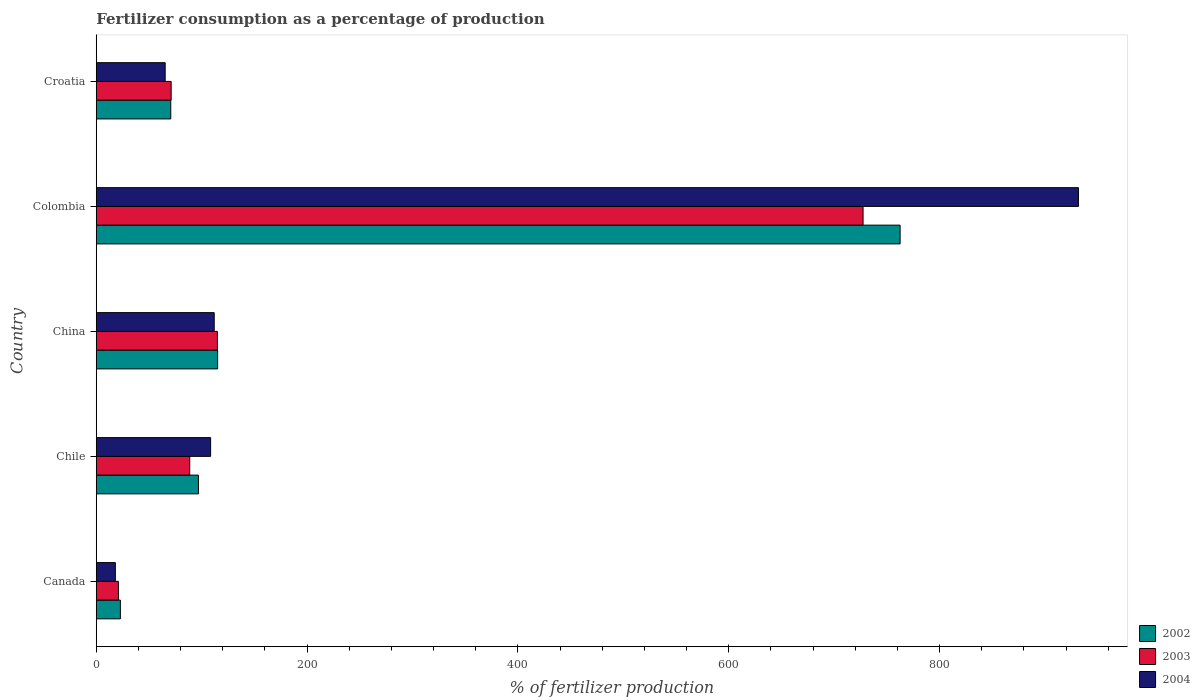How many different coloured bars are there?
Offer a very short reply. 3. Are the number of bars per tick equal to the number of legend labels?
Ensure brevity in your answer.  Yes. How many bars are there on the 1st tick from the top?
Give a very brief answer. 3. What is the label of the 2nd group of bars from the top?
Keep it short and to the point. Colombia. What is the percentage of fertilizers consumed in 2002 in Colombia?
Ensure brevity in your answer.  762.5. Across all countries, what is the maximum percentage of fertilizers consumed in 2003?
Provide a succinct answer. 727.37. Across all countries, what is the minimum percentage of fertilizers consumed in 2002?
Provide a succinct answer. 22.89. In which country was the percentage of fertilizers consumed in 2004 maximum?
Make the answer very short. Colombia. In which country was the percentage of fertilizers consumed in 2003 minimum?
Ensure brevity in your answer.  Canada. What is the total percentage of fertilizers consumed in 2003 in the graph?
Give a very brief answer. 1022.99. What is the difference between the percentage of fertilizers consumed in 2004 in Canada and that in Chile?
Provide a succinct answer. -90.37. What is the difference between the percentage of fertilizers consumed in 2003 in Canada and the percentage of fertilizers consumed in 2002 in Colombia?
Offer a very short reply. -741.5. What is the average percentage of fertilizers consumed in 2004 per country?
Give a very brief answer. 247.1. What is the difference between the percentage of fertilizers consumed in 2002 and percentage of fertilizers consumed in 2003 in Colombia?
Your answer should be compact. 35.14. In how many countries, is the percentage of fertilizers consumed in 2002 greater than 240 %?
Ensure brevity in your answer.  1. What is the ratio of the percentage of fertilizers consumed in 2003 in Colombia to that in Croatia?
Ensure brevity in your answer.  10.24. What is the difference between the highest and the second highest percentage of fertilizers consumed in 2003?
Your response must be concise. 612.45. What is the difference between the highest and the lowest percentage of fertilizers consumed in 2002?
Make the answer very short. 739.62. What does the 3rd bar from the top in Chile represents?
Keep it short and to the point. 2002. What does the 3rd bar from the bottom in Croatia represents?
Ensure brevity in your answer.  2004. How many bars are there?
Your answer should be compact. 15. Are all the bars in the graph horizontal?
Provide a short and direct response. Yes. Are the values on the major ticks of X-axis written in scientific E-notation?
Provide a succinct answer. No. How many legend labels are there?
Ensure brevity in your answer.  3. How are the legend labels stacked?
Your answer should be compact. Vertical. What is the title of the graph?
Give a very brief answer. Fertilizer consumption as a percentage of production. What is the label or title of the X-axis?
Make the answer very short. % of fertilizer production. What is the % of fertilizer production in 2002 in Canada?
Your answer should be compact. 22.89. What is the % of fertilizer production of 2003 in Canada?
Keep it short and to the point. 21. What is the % of fertilizer production in 2004 in Canada?
Make the answer very short. 18.12. What is the % of fertilizer production in 2002 in Chile?
Your answer should be very brief. 96.91. What is the % of fertilizer production of 2003 in Chile?
Ensure brevity in your answer.  88.66. What is the % of fertilizer production of 2004 in Chile?
Make the answer very short. 108.48. What is the % of fertilizer production in 2002 in China?
Your answer should be compact. 115.12. What is the % of fertilizer production in 2003 in China?
Offer a very short reply. 114.92. What is the % of fertilizer production in 2004 in China?
Ensure brevity in your answer.  111.88. What is the % of fertilizer production of 2002 in Colombia?
Provide a succinct answer. 762.5. What is the % of fertilizer production of 2003 in Colombia?
Offer a terse response. 727.37. What is the % of fertilizer production in 2004 in Colombia?
Your response must be concise. 931.67. What is the % of fertilizer production of 2002 in Croatia?
Ensure brevity in your answer.  70.67. What is the % of fertilizer production in 2003 in Croatia?
Your answer should be compact. 71.05. What is the % of fertilizer production in 2004 in Croatia?
Make the answer very short. 65.37. Across all countries, what is the maximum % of fertilizer production in 2002?
Keep it short and to the point. 762.5. Across all countries, what is the maximum % of fertilizer production in 2003?
Provide a succinct answer. 727.37. Across all countries, what is the maximum % of fertilizer production of 2004?
Your response must be concise. 931.67. Across all countries, what is the minimum % of fertilizer production of 2002?
Your answer should be very brief. 22.89. Across all countries, what is the minimum % of fertilizer production of 2003?
Offer a very short reply. 21. Across all countries, what is the minimum % of fertilizer production in 2004?
Offer a very short reply. 18.12. What is the total % of fertilizer production in 2002 in the graph?
Offer a terse response. 1068.1. What is the total % of fertilizer production in 2003 in the graph?
Your answer should be compact. 1022.99. What is the total % of fertilizer production in 2004 in the graph?
Your answer should be very brief. 1235.52. What is the difference between the % of fertilizer production of 2002 in Canada and that in Chile?
Your answer should be compact. -74.03. What is the difference between the % of fertilizer production of 2003 in Canada and that in Chile?
Offer a terse response. -67.66. What is the difference between the % of fertilizer production in 2004 in Canada and that in Chile?
Offer a terse response. -90.37. What is the difference between the % of fertilizer production in 2002 in Canada and that in China?
Your answer should be compact. -92.24. What is the difference between the % of fertilizer production in 2003 in Canada and that in China?
Offer a very short reply. -93.91. What is the difference between the % of fertilizer production of 2004 in Canada and that in China?
Offer a terse response. -93.77. What is the difference between the % of fertilizer production in 2002 in Canada and that in Colombia?
Your answer should be compact. -739.62. What is the difference between the % of fertilizer production in 2003 in Canada and that in Colombia?
Your response must be concise. -706.36. What is the difference between the % of fertilizer production in 2004 in Canada and that in Colombia?
Ensure brevity in your answer.  -913.55. What is the difference between the % of fertilizer production in 2002 in Canada and that in Croatia?
Provide a succinct answer. -47.78. What is the difference between the % of fertilizer production of 2003 in Canada and that in Croatia?
Keep it short and to the point. -50.04. What is the difference between the % of fertilizer production of 2004 in Canada and that in Croatia?
Keep it short and to the point. -47.26. What is the difference between the % of fertilizer production of 2002 in Chile and that in China?
Keep it short and to the point. -18.21. What is the difference between the % of fertilizer production in 2003 in Chile and that in China?
Your answer should be compact. -26.26. What is the difference between the % of fertilizer production in 2004 in Chile and that in China?
Offer a terse response. -3.4. What is the difference between the % of fertilizer production in 2002 in Chile and that in Colombia?
Your answer should be very brief. -665.59. What is the difference between the % of fertilizer production in 2003 in Chile and that in Colombia?
Your response must be concise. -638.71. What is the difference between the % of fertilizer production in 2004 in Chile and that in Colombia?
Offer a terse response. -823.18. What is the difference between the % of fertilizer production of 2002 in Chile and that in Croatia?
Your answer should be very brief. 26.24. What is the difference between the % of fertilizer production in 2003 in Chile and that in Croatia?
Ensure brevity in your answer.  17.61. What is the difference between the % of fertilizer production in 2004 in Chile and that in Croatia?
Ensure brevity in your answer.  43.11. What is the difference between the % of fertilizer production of 2002 in China and that in Colombia?
Provide a short and direct response. -647.38. What is the difference between the % of fertilizer production of 2003 in China and that in Colombia?
Make the answer very short. -612.45. What is the difference between the % of fertilizer production in 2004 in China and that in Colombia?
Ensure brevity in your answer.  -819.79. What is the difference between the % of fertilizer production of 2002 in China and that in Croatia?
Your answer should be compact. 44.45. What is the difference between the % of fertilizer production of 2003 in China and that in Croatia?
Your answer should be very brief. 43.87. What is the difference between the % of fertilizer production of 2004 in China and that in Croatia?
Provide a succinct answer. 46.51. What is the difference between the % of fertilizer production in 2002 in Colombia and that in Croatia?
Make the answer very short. 691.83. What is the difference between the % of fertilizer production in 2003 in Colombia and that in Croatia?
Provide a succinct answer. 656.32. What is the difference between the % of fertilizer production in 2004 in Colombia and that in Croatia?
Your response must be concise. 866.29. What is the difference between the % of fertilizer production in 2002 in Canada and the % of fertilizer production in 2003 in Chile?
Offer a very short reply. -65.77. What is the difference between the % of fertilizer production in 2002 in Canada and the % of fertilizer production in 2004 in Chile?
Provide a short and direct response. -85.6. What is the difference between the % of fertilizer production of 2003 in Canada and the % of fertilizer production of 2004 in Chile?
Your answer should be very brief. -87.48. What is the difference between the % of fertilizer production in 2002 in Canada and the % of fertilizer production in 2003 in China?
Provide a succinct answer. -92.03. What is the difference between the % of fertilizer production of 2002 in Canada and the % of fertilizer production of 2004 in China?
Your answer should be compact. -88.99. What is the difference between the % of fertilizer production of 2003 in Canada and the % of fertilizer production of 2004 in China?
Your response must be concise. -90.88. What is the difference between the % of fertilizer production in 2002 in Canada and the % of fertilizer production in 2003 in Colombia?
Provide a short and direct response. -704.48. What is the difference between the % of fertilizer production of 2002 in Canada and the % of fertilizer production of 2004 in Colombia?
Your response must be concise. -908.78. What is the difference between the % of fertilizer production of 2003 in Canada and the % of fertilizer production of 2004 in Colombia?
Provide a short and direct response. -910.66. What is the difference between the % of fertilizer production in 2002 in Canada and the % of fertilizer production in 2003 in Croatia?
Offer a terse response. -48.16. What is the difference between the % of fertilizer production in 2002 in Canada and the % of fertilizer production in 2004 in Croatia?
Offer a terse response. -42.49. What is the difference between the % of fertilizer production of 2003 in Canada and the % of fertilizer production of 2004 in Croatia?
Your answer should be compact. -44.37. What is the difference between the % of fertilizer production of 2002 in Chile and the % of fertilizer production of 2003 in China?
Keep it short and to the point. -18. What is the difference between the % of fertilizer production of 2002 in Chile and the % of fertilizer production of 2004 in China?
Offer a very short reply. -14.97. What is the difference between the % of fertilizer production in 2003 in Chile and the % of fertilizer production in 2004 in China?
Give a very brief answer. -23.22. What is the difference between the % of fertilizer production in 2002 in Chile and the % of fertilizer production in 2003 in Colombia?
Ensure brevity in your answer.  -630.45. What is the difference between the % of fertilizer production of 2002 in Chile and the % of fertilizer production of 2004 in Colombia?
Your answer should be very brief. -834.75. What is the difference between the % of fertilizer production of 2003 in Chile and the % of fertilizer production of 2004 in Colombia?
Your answer should be very brief. -843.01. What is the difference between the % of fertilizer production of 2002 in Chile and the % of fertilizer production of 2003 in Croatia?
Your answer should be compact. 25.87. What is the difference between the % of fertilizer production of 2002 in Chile and the % of fertilizer production of 2004 in Croatia?
Your answer should be compact. 31.54. What is the difference between the % of fertilizer production in 2003 in Chile and the % of fertilizer production in 2004 in Croatia?
Provide a short and direct response. 23.29. What is the difference between the % of fertilizer production of 2002 in China and the % of fertilizer production of 2003 in Colombia?
Your answer should be very brief. -612.25. What is the difference between the % of fertilizer production of 2002 in China and the % of fertilizer production of 2004 in Colombia?
Provide a short and direct response. -816.54. What is the difference between the % of fertilizer production in 2003 in China and the % of fertilizer production in 2004 in Colombia?
Give a very brief answer. -816.75. What is the difference between the % of fertilizer production of 2002 in China and the % of fertilizer production of 2003 in Croatia?
Your answer should be very brief. 44.07. What is the difference between the % of fertilizer production of 2002 in China and the % of fertilizer production of 2004 in Croatia?
Give a very brief answer. 49.75. What is the difference between the % of fertilizer production of 2003 in China and the % of fertilizer production of 2004 in Croatia?
Your answer should be compact. 49.54. What is the difference between the % of fertilizer production of 2002 in Colombia and the % of fertilizer production of 2003 in Croatia?
Offer a very short reply. 691.46. What is the difference between the % of fertilizer production in 2002 in Colombia and the % of fertilizer production in 2004 in Croatia?
Your answer should be compact. 697.13. What is the difference between the % of fertilizer production of 2003 in Colombia and the % of fertilizer production of 2004 in Croatia?
Give a very brief answer. 661.99. What is the average % of fertilizer production of 2002 per country?
Provide a succinct answer. 213.62. What is the average % of fertilizer production of 2003 per country?
Give a very brief answer. 204.6. What is the average % of fertilizer production of 2004 per country?
Make the answer very short. 247.1. What is the difference between the % of fertilizer production in 2002 and % of fertilizer production in 2003 in Canada?
Provide a succinct answer. 1.88. What is the difference between the % of fertilizer production in 2002 and % of fertilizer production in 2004 in Canada?
Offer a terse response. 4.77. What is the difference between the % of fertilizer production in 2003 and % of fertilizer production in 2004 in Canada?
Give a very brief answer. 2.89. What is the difference between the % of fertilizer production in 2002 and % of fertilizer production in 2003 in Chile?
Keep it short and to the point. 8.25. What is the difference between the % of fertilizer production in 2002 and % of fertilizer production in 2004 in Chile?
Your answer should be compact. -11.57. What is the difference between the % of fertilizer production in 2003 and % of fertilizer production in 2004 in Chile?
Your response must be concise. -19.82. What is the difference between the % of fertilizer production of 2002 and % of fertilizer production of 2003 in China?
Offer a terse response. 0.21. What is the difference between the % of fertilizer production in 2002 and % of fertilizer production in 2004 in China?
Give a very brief answer. 3.24. What is the difference between the % of fertilizer production of 2003 and % of fertilizer production of 2004 in China?
Your answer should be very brief. 3.03. What is the difference between the % of fertilizer production of 2002 and % of fertilizer production of 2003 in Colombia?
Give a very brief answer. 35.14. What is the difference between the % of fertilizer production in 2002 and % of fertilizer production in 2004 in Colombia?
Your answer should be very brief. -169.16. What is the difference between the % of fertilizer production of 2003 and % of fertilizer production of 2004 in Colombia?
Your answer should be compact. -204.3. What is the difference between the % of fertilizer production in 2002 and % of fertilizer production in 2003 in Croatia?
Offer a very short reply. -0.38. What is the difference between the % of fertilizer production in 2002 and % of fertilizer production in 2004 in Croatia?
Keep it short and to the point. 5.3. What is the difference between the % of fertilizer production of 2003 and % of fertilizer production of 2004 in Croatia?
Give a very brief answer. 5.67. What is the ratio of the % of fertilizer production of 2002 in Canada to that in Chile?
Ensure brevity in your answer.  0.24. What is the ratio of the % of fertilizer production of 2003 in Canada to that in Chile?
Keep it short and to the point. 0.24. What is the ratio of the % of fertilizer production of 2004 in Canada to that in Chile?
Give a very brief answer. 0.17. What is the ratio of the % of fertilizer production of 2002 in Canada to that in China?
Your answer should be compact. 0.2. What is the ratio of the % of fertilizer production in 2003 in Canada to that in China?
Offer a very short reply. 0.18. What is the ratio of the % of fertilizer production of 2004 in Canada to that in China?
Ensure brevity in your answer.  0.16. What is the ratio of the % of fertilizer production in 2002 in Canada to that in Colombia?
Ensure brevity in your answer.  0.03. What is the ratio of the % of fertilizer production in 2003 in Canada to that in Colombia?
Your response must be concise. 0.03. What is the ratio of the % of fertilizer production of 2004 in Canada to that in Colombia?
Your answer should be compact. 0.02. What is the ratio of the % of fertilizer production in 2002 in Canada to that in Croatia?
Your answer should be very brief. 0.32. What is the ratio of the % of fertilizer production of 2003 in Canada to that in Croatia?
Offer a very short reply. 0.3. What is the ratio of the % of fertilizer production in 2004 in Canada to that in Croatia?
Make the answer very short. 0.28. What is the ratio of the % of fertilizer production in 2002 in Chile to that in China?
Make the answer very short. 0.84. What is the ratio of the % of fertilizer production in 2003 in Chile to that in China?
Offer a terse response. 0.77. What is the ratio of the % of fertilizer production in 2004 in Chile to that in China?
Offer a very short reply. 0.97. What is the ratio of the % of fertilizer production of 2002 in Chile to that in Colombia?
Offer a terse response. 0.13. What is the ratio of the % of fertilizer production of 2003 in Chile to that in Colombia?
Keep it short and to the point. 0.12. What is the ratio of the % of fertilizer production of 2004 in Chile to that in Colombia?
Your response must be concise. 0.12. What is the ratio of the % of fertilizer production in 2002 in Chile to that in Croatia?
Offer a very short reply. 1.37. What is the ratio of the % of fertilizer production of 2003 in Chile to that in Croatia?
Provide a succinct answer. 1.25. What is the ratio of the % of fertilizer production of 2004 in Chile to that in Croatia?
Offer a terse response. 1.66. What is the ratio of the % of fertilizer production in 2002 in China to that in Colombia?
Offer a terse response. 0.15. What is the ratio of the % of fertilizer production in 2003 in China to that in Colombia?
Provide a short and direct response. 0.16. What is the ratio of the % of fertilizer production of 2004 in China to that in Colombia?
Offer a very short reply. 0.12. What is the ratio of the % of fertilizer production in 2002 in China to that in Croatia?
Provide a succinct answer. 1.63. What is the ratio of the % of fertilizer production of 2003 in China to that in Croatia?
Keep it short and to the point. 1.62. What is the ratio of the % of fertilizer production of 2004 in China to that in Croatia?
Give a very brief answer. 1.71. What is the ratio of the % of fertilizer production in 2002 in Colombia to that in Croatia?
Offer a terse response. 10.79. What is the ratio of the % of fertilizer production in 2003 in Colombia to that in Croatia?
Make the answer very short. 10.24. What is the ratio of the % of fertilizer production of 2004 in Colombia to that in Croatia?
Make the answer very short. 14.25. What is the difference between the highest and the second highest % of fertilizer production in 2002?
Your answer should be compact. 647.38. What is the difference between the highest and the second highest % of fertilizer production in 2003?
Give a very brief answer. 612.45. What is the difference between the highest and the second highest % of fertilizer production of 2004?
Your answer should be compact. 819.79. What is the difference between the highest and the lowest % of fertilizer production in 2002?
Your answer should be very brief. 739.62. What is the difference between the highest and the lowest % of fertilizer production of 2003?
Your answer should be compact. 706.36. What is the difference between the highest and the lowest % of fertilizer production in 2004?
Offer a very short reply. 913.55. 